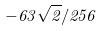Convert formula to latex. <formula><loc_0><loc_0><loc_500><loc_500>- 6 3 \sqrt { 2 } / 2 5 6</formula> 